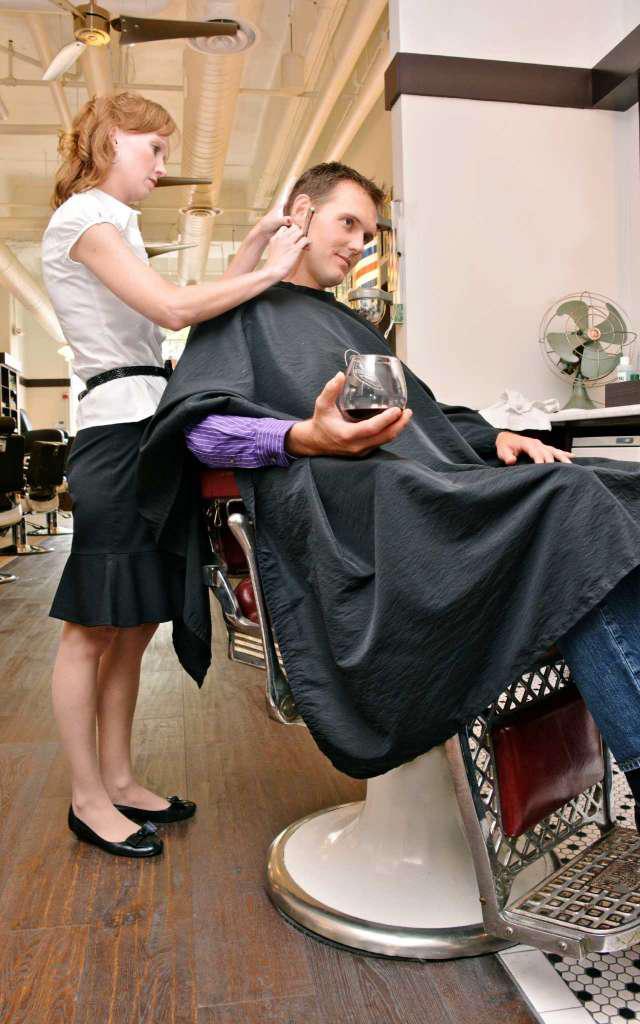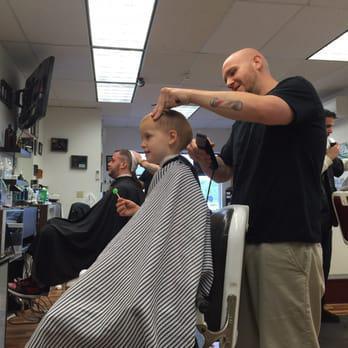The first image is the image on the left, the second image is the image on the right. For the images displayed, is the sentence "An image shows at least one person standing by an outdoor barber pole." factually correct? Answer yes or no. No. The first image is the image on the left, the second image is the image on the right. Analyze the images presented: Is the assertion "In one image, a child is draped in a barber's cape and getting a haircut" valid? Answer yes or no. Yes. 